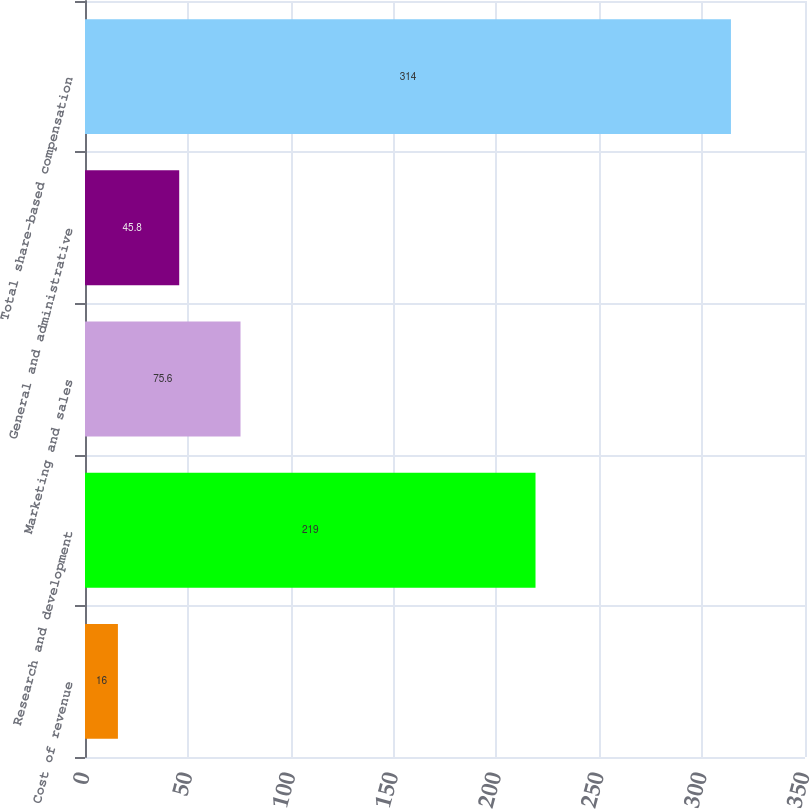Convert chart to OTSL. <chart><loc_0><loc_0><loc_500><loc_500><bar_chart><fcel>Cost of revenue<fcel>Research and development<fcel>Marketing and sales<fcel>General and administrative<fcel>Total share-based compensation<nl><fcel>16<fcel>219<fcel>75.6<fcel>45.8<fcel>314<nl></chart> 